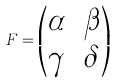<formula> <loc_0><loc_0><loc_500><loc_500>F = \begin{pmatrix} \alpha & \beta \\ \gamma & \delta \end{pmatrix}</formula> 